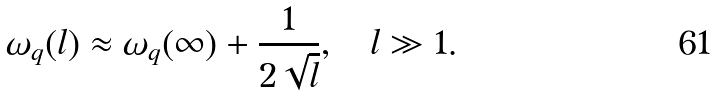<formula> <loc_0><loc_0><loc_500><loc_500>\omega _ { q } ( l ) \approx \omega _ { q } ( \infty ) + \frac { 1 } { 2 \sqrt { l } } , \quad l \gg 1 .</formula> 